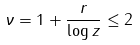<formula> <loc_0><loc_0><loc_500><loc_500>\nu = 1 + \frac { r } { \log z } \leq 2</formula> 